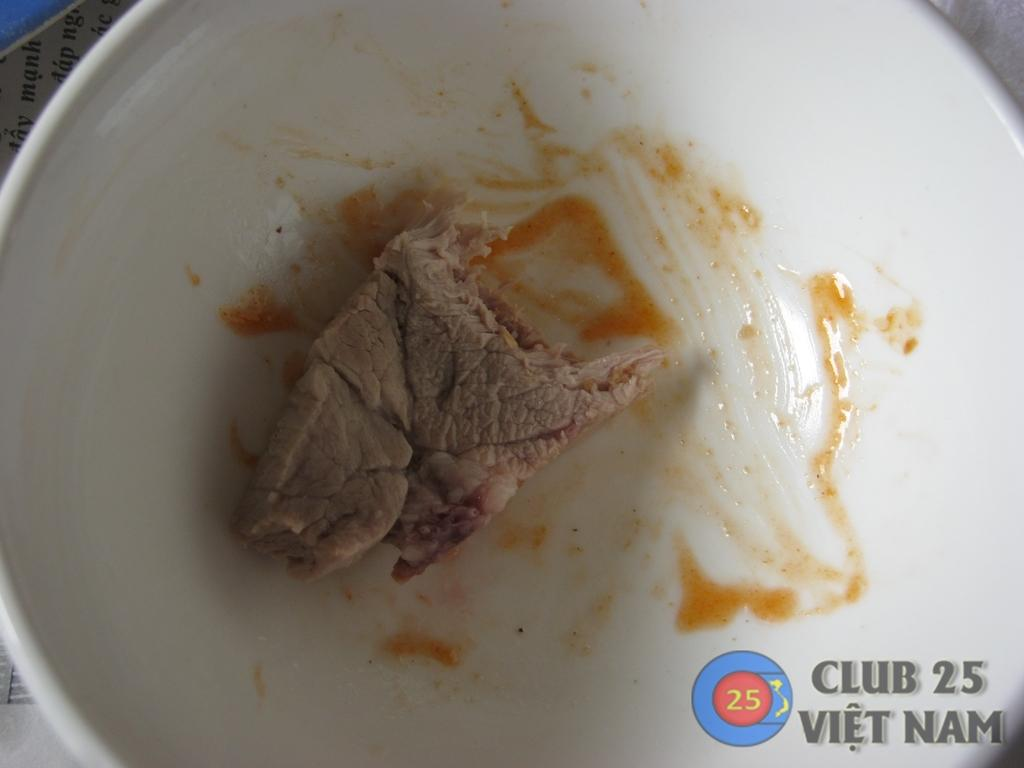What is on the plate in the image? There is a piece of meat on the plate. What accompanies the meat on the plate? There is a sauce beside the meat. What might be used to serve the meat and sauce? The plate in the image is used to serve the meat and sauce. What type of star is visible in the image? There is no star visible in the image; it features a plate with a piece of meat and sauce. 